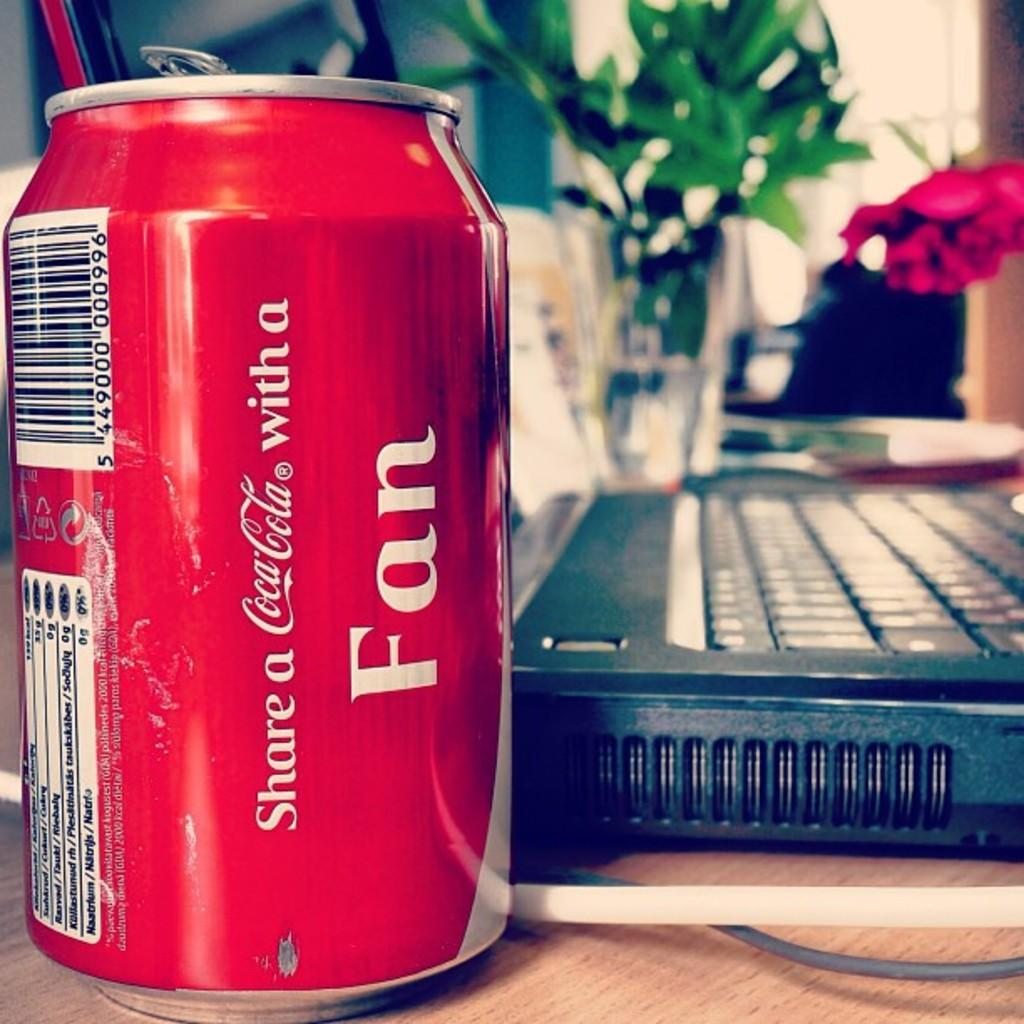<image>
Relay a brief, clear account of the picture shown. A Coca-Cola can sits next to a laptop computer. 